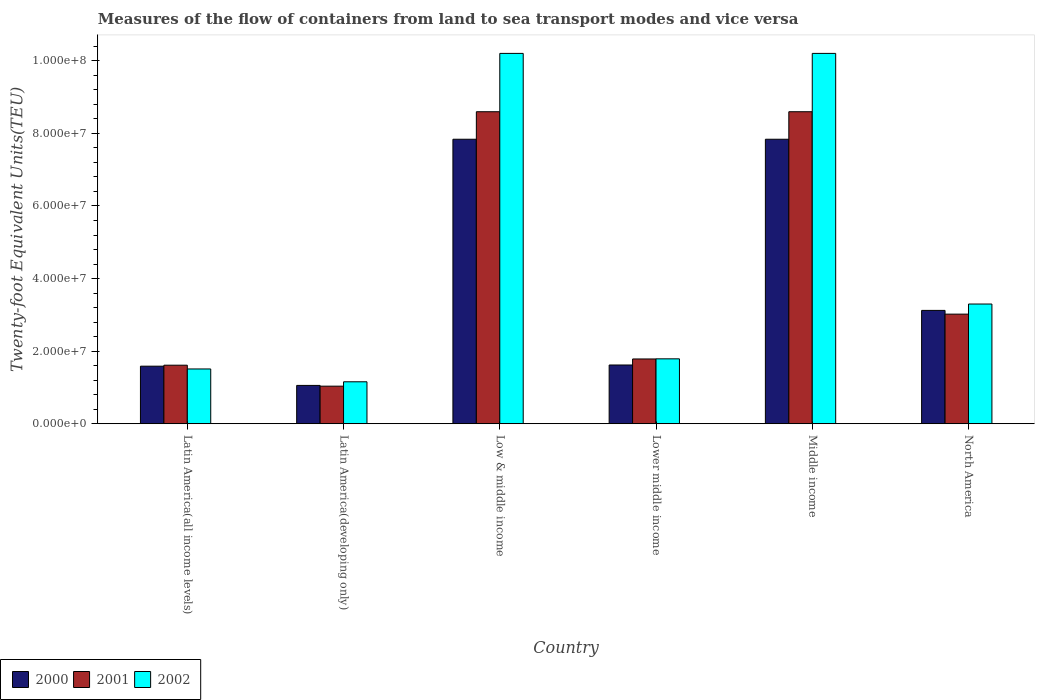How many different coloured bars are there?
Your answer should be very brief. 3. How many groups of bars are there?
Make the answer very short. 6. Are the number of bars per tick equal to the number of legend labels?
Offer a very short reply. Yes. How many bars are there on the 1st tick from the left?
Provide a short and direct response. 3. In how many cases, is the number of bars for a given country not equal to the number of legend labels?
Offer a very short reply. 0. What is the container port traffic in 2002 in Latin America(developing only)?
Offer a terse response. 1.16e+07. Across all countries, what is the maximum container port traffic in 2001?
Ensure brevity in your answer.  8.60e+07. Across all countries, what is the minimum container port traffic in 2000?
Your answer should be compact. 1.06e+07. In which country was the container port traffic in 2001 maximum?
Give a very brief answer. Low & middle income. In which country was the container port traffic in 2001 minimum?
Make the answer very short. Latin America(developing only). What is the total container port traffic in 2001 in the graph?
Provide a short and direct response. 2.46e+08. What is the difference between the container port traffic in 2001 in Lower middle income and that in North America?
Provide a succinct answer. -1.24e+07. What is the difference between the container port traffic in 2002 in Middle income and the container port traffic in 2000 in Lower middle income?
Your answer should be very brief. 8.59e+07. What is the average container port traffic in 2001 per country?
Your answer should be very brief. 4.11e+07. What is the difference between the container port traffic of/in 2002 and container port traffic of/in 2000 in Lower middle income?
Your answer should be very brief. 1.70e+06. In how many countries, is the container port traffic in 2001 greater than 72000000 TEU?
Make the answer very short. 2. What is the ratio of the container port traffic in 2002 in Latin America(all income levels) to that in Low & middle income?
Make the answer very short. 0.15. Is the difference between the container port traffic in 2002 in Latin America(developing only) and Low & middle income greater than the difference between the container port traffic in 2000 in Latin America(developing only) and Low & middle income?
Make the answer very short. No. What is the difference between the highest and the second highest container port traffic in 2001?
Provide a short and direct response. 5.58e+07. What is the difference between the highest and the lowest container port traffic in 2001?
Provide a succinct answer. 7.56e+07. In how many countries, is the container port traffic in 2000 greater than the average container port traffic in 2000 taken over all countries?
Make the answer very short. 2. Is the sum of the container port traffic in 2000 in Lower middle income and Middle income greater than the maximum container port traffic in 2001 across all countries?
Offer a terse response. Yes. What does the 3rd bar from the left in Lower middle income represents?
Ensure brevity in your answer.  2002. What does the 1st bar from the right in Middle income represents?
Offer a terse response. 2002. Is it the case that in every country, the sum of the container port traffic in 2000 and container port traffic in 2001 is greater than the container port traffic in 2002?
Provide a succinct answer. Yes. How many bars are there?
Offer a terse response. 18. What is the difference between two consecutive major ticks on the Y-axis?
Make the answer very short. 2.00e+07. Does the graph contain grids?
Your response must be concise. No. What is the title of the graph?
Offer a terse response. Measures of the flow of containers from land to sea transport modes and vice versa. Does "1984" appear as one of the legend labels in the graph?
Your response must be concise. No. What is the label or title of the X-axis?
Provide a succinct answer. Country. What is the label or title of the Y-axis?
Ensure brevity in your answer.  Twenty-foot Equivalent Units(TEU). What is the Twenty-foot Equivalent Units(TEU) in 2000 in Latin America(all income levels)?
Your response must be concise. 1.59e+07. What is the Twenty-foot Equivalent Units(TEU) in 2001 in Latin America(all income levels)?
Ensure brevity in your answer.  1.61e+07. What is the Twenty-foot Equivalent Units(TEU) in 2002 in Latin America(all income levels)?
Your response must be concise. 1.51e+07. What is the Twenty-foot Equivalent Units(TEU) in 2000 in Latin America(developing only)?
Give a very brief answer. 1.06e+07. What is the Twenty-foot Equivalent Units(TEU) in 2001 in Latin America(developing only)?
Offer a very short reply. 1.04e+07. What is the Twenty-foot Equivalent Units(TEU) in 2002 in Latin America(developing only)?
Your response must be concise. 1.16e+07. What is the Twenty-foot Equivalent Units(TEU) in 2000 in Low & middle income?
Your answer should be very brief. 7.84e+07. What is the Twenty-foot Equivalent Units(TEU) in 2001 in Low & middle income?
Provide a succinct answer. 8.60e+07. What is the Twenty-foot Equivalent Units(TEU) of 2002 in Low & middle income?
Your response must be concise. 1.02e+08. What is the Twenty-foot Equivalent Units(TEU) of 2000 in Lower middle income?
Provide a short and direct response. 1.62e+07. What is the Twenty-foot Equivalent Units(TEU) of 2001 in Lower middle income?
Ensure brevity in your answer.  1.78e+07. What is the Twenty-foot Equivalent Units(TEU) of 2002 in Lower middle income?
Your response must be concise. 1.79e+07. What is the Twenty-foot Equivalent Units(TEU) in 2000 in Middle income?
Make the answer very short. 7.84e+07. What is the Twenty-foot Equivalent Units(TEU) of 2001 in Middle income?
Offer a terse response. 8.60e+07. What is the Twenty-foot Equivalent Units(TEU) of 2002 in Middle income?
Ensure brevity in your answer.  1.02e+08. What is the Twenty-foot Equivalent Units(TEU) of 2000 in North America?
Ensure brevity in your answer.  3.12e+07. What is the Twenty-foot Equivalent Units(TEU) in 2001 in North America?
Ensure brevity in your answer.  3.02e+07. What is the Twenty-foot Equivalent Units(TEU) in 2002 in North America?
Ensure brevity in your answer.  3.30e+07. Across all countries, what is the maximum Twenty-foot Equivalent Units(TEU) of 2000?
Provide a succinct answer. 7.84e+07. Across all countries, what is the maximum Twenty-foot Equivalent Units(TEU) of 2001?
Give a very brief answer. 8.60e+07. Across all countries, what is the maximum Twenty-foot Equivalent Units(TEU) in 2002?
Your answer should be compact. 1.02e+08. Across all countries, what is the minimum Twenty-foot Equivalent Units(TEU) of 2000?
Keep it short and to the point. 1.06e+07. Across all countries, what is the minimum Twenty-foot Equivalent Units(TEU) of 2001?
Your response must be concise. 1.04e+07. Across all countries, what is the minimum Twenty-foot Equivalent Units(TEU) of 2002?
Your answer should be compact. 1.16e+07. What is the total Twenty-foot Equivalent Units(TEU) of 2000 in the graph?
Make the answer very short. 2.31e+08. What is the total Twenty-foot Equivalent Units(TEU) in 2001 in the graph?
Make the answer very short. 2.46e+08. What is the total Twenty-foot Equivalent Units(TEU) in 2002 in the graph?
Provide a short and direct response. 2.82e+08. What is the difference between the Twenty-foot Equivalent Units(TEU) of 2000 in Latin America(all income levels) and that in Latin America(developing only)?
Your answer should be compact. 5.30e+06. What is the difference between the Twenty-foot Equivalent Units(TEU) of 2001 in Latin America(all income levels) and that in Latin America(developing only)?
Ensure brevity in your answer.  5.78e+06. What is the difference between the Twenty-foot Equivalent Units(TEU) in 2002 in Latin America(all income levels) and that in Latin America(developing only)?
Provide a succinct answer. 3.53e+06. What is the difference between the Twenty-foot Equivalent Units(TEU) of 2000 in Latin America(all income levels) and that in Low & middle income?
Your answer should be compact. -6.25e+07. What is the difference between the Twenty-foot Equivalent Units(TEU) in 2001 in Latin America(all income levels) and that in Low & middle income?
Your response must be concise. -6.98e+07. What is the difference between the Twenty-foot Equivalent Units(TEU) in 2002 in Latin America(all income levels) and that in Low & middle income?
Make the answer very short. -8.69e+07. What is the difference between the Twenty-foot Equivalent Units(TEU) of 2000 in Latin America(all income levels) and that in Lower middle income?
Keep it short and to the point. -3.24e+05. What is the difference between the Twenty-foot Equivalent Units(TEU) of 2001 in Latin America(all income levels) and that in Lower middle income?
Your response must be concise. -1.72e+06. What is the difference between the Twenty-foot Equivalent Units(TEU) in 2002 in Latin America(all income levels) and that in Lower middle income?
Your answer should be compact. -2.79e+06. What is the difference between the Twenty-foot Equivalent Units(TEU) of 2000 in Latin America(all income levels) and that in Middle income?
Make the answer very short. -6.25e+07. What is the difference between the Twenty-foot Equivalent Units(TEU) in 2001 in Latin America(all income levels) and that in Middle income?
Offer a terse response. -6.98e+07. What is the difference between the Twenty-foot Equivalent Units(TEU) of 2002 in Latin America(all income levels) and that in Middle income?
Offer a very short reply. -8.69e+07. What is the difference between the Twenty-foot Equivalent Units(TEU) in 2000 in Latin America(all income levels) and that in North America?
Your answer should be very brief. -1.54e+07. What is the difference between the Twenty-foot Equivalent Units(TEU) in 2001 in Latin America(all income levels) and that in North America?
Provide a short and direct response. -1.41e+07. What is the difference between the Twenty-foot Equivalent Units(TEU) of 2002 in Latin America(all income levels) and that in North America?
Ensure brevity in your answer.  -1.79e+07. What is the difference between the Twenty-foot Equivalent Units(TEU) of 2000 in Latin America(developing only) and that in Low & middle income?
Offer a terse response. -6.78e+07. What is the difference between the Twenty-foot Equivalent Units(TEU) in 2001 in Latin America(developing only) and that in Low & middle income?
Provide a succinct answer. -7.56e+07. What is the difference between the Twenty-foot Equivalent Units(TEU) in 2002 in Latin America(developing only) and that in Low & middle income?
Your answer should be compact. -9.05e+07. What is the difference between the Twenty-foot Equivalent Units(TEU) of 2000 in Latin America(developing only) and that in Lower middle income?
Provide a short and direct response. -5.63e+06. What is the difference between the Twenty-foot Equivalent Units(TEU) of 2001 in Latin America(developing only) and that in Lower middle income?
Make the answer very short. -7.49e+06. What is the difference between the Twenty-foot Equivalent Units(TEU) of 2002 in Latin America(developing only) and that in Lower middle income?
Make the answer very short. -6.33e+06. What is the difference between the Twenty-foot Equivalent Units(TEU) in 2000 in Latin America(developing only) and that in Middle income?
Make the answer very short. -6.78e+07. What is the difference between the Twenty-foot Equivalent Units(TEU) in 2001 in Latin America(developing only) and that in Middle income?
Provide a succinct answer. -7.56e+07. What is the difference between the Twenty-foot Equivalent Units(TEU) in 2002 in Latin America(developing only) and that in Middle income?
Give a very brief answer. -9.05e+07. What is the difference between the Twenty-foot Equivalent Units(TEU) in 2000 in Latin America(developing only) and that in North America?
Give a very brief answer. -2.07e+07. What is the difference between the Twenty-foot Equivalent Units(TEU) of 2001 in Latin America(developing only) and that in North America?
Ensure brevity in your answer.  -1.98e+07. What is the difference between the Twenty-foot Equivalent Units(TEU) of 2002 in Latin America(developing only) and that in North America?
Give a very brief answer. -2.14e+07. What is the difference between the Twenty-foot Equivalent Units(TEU) in 2000 in Low & middle income and that in Lower middle income?
Keep it short and to the point. 6.22e+07. What is the difference between the Twenty-foot Equivalent Units(TEU) in 2001 in Low & middle income and that in Lower middle income?
Your answer should be compact. 6.81e+07. What is the difference between the Twenty-foot Equivalent Units(TEU) in 2002 in Low & middle income and that in Lower middle income?
Give a very brief answer. 8.42e+07. What is the difference between the Twenty-foot Equivalent Units(TEU) in 2000 in Low & middle income and that in Middle income?
Ensure brevity in your answer.  0. What is the difference between the Twenty-foot Equivalent Units(TEU) of 2001 in Low & middle income and that in Middle income?
Make the answer very short. 0. What is the difference between the Twenty-foot Equivalent Units(TEU) in 2000 in Low & middle income and that in North America?
Provide a succinct answer. 4.72e+07. What is the difference between the Twenty-foot Equivalent Units(TEU) in 2001 in Low & middle income and that in North America?
Your answer should be very brief. 5.58e+07. What is the difference between the Twenty-foot Equivalent Units(TEU) of 2002 in Low & middle income and that in North America?
Give a very brief answer. 6.91e+07. What is the difference between the Twenty-foot Equivalent Units(TEU) in 2000 in Lower middle income and that in Middle income?
Your answer should be very brief. -6.22e+07. What is the difference between the Twenty-foot Equivalent Units(TEU) in 2001 in Lower middle income and that in Middle income?
Provide a short and direct response. -6.81e+07. What is the difference between the Twenty-foot Equivalent Units(TEU) of 2002 in Lower middle income and that in Middle income?
Give a very brief answer. -8.42e+07. What is the difference between the Twenty-foot Equivalent Units(TEU) in 2000 in Lower middle income and that in North America?
Ensure brevity in your answer.  -1.50e+07. What is the difference between the Twenty-foot Equivalent Units(TEU) of 2001 in Lower middle income and that in North America?
Ensure brevity in your answer.  -1.24e+07. What is the difference between the Twenty-foot Equivalent Units(TEU) in 2002 in Lower middle income and that in North America?
Offer a very short reply. -1.51e+07. What is the difference between the Twenty-foot Equivalent Units(TEU) in 2000 in Middle income and that in North America?
Ensure brevity in your answer.  4.72e+07. What is the difference between the Twenty-foot Equivalent Units(TEU) of 2001 in Middle income and that in North America?
Provide a succinct answer. 5.58e+07. What is the difference between the Twenty-foot Equivalent Units(TEU) of 2002 in Middle income and that in North America?
Your answer should be compact. 6.91e+07. What is the difference between the Twenty-foot Equivalent Units(TEU) of 2000 in Latin America(all income levels) and the Twenty-foot Equivalent Units(TEU) of 2001 in Latin America(developing only)?
Offer a very short reply. 5.51e+06. What is the difference between the Twenty-foot Equivalent Units(TEU) of 2000 in Latin America(all income levels) and the Twenty-foot Equivalent Units(TEU) of 2002 in Latin America(developing only)?
Keep it short and to the point. 4.30e+06. What is the difference between the Twenty-foot Equivalent Units(TEU) of 2001 in Latin America(all income levels) and the Twenty-foot Equivalent Units(TEU) of 2002 in Latin America(developing only)?
Ensure brevity in your answer.  4.57e+06. What is the difference between the Twenty-foot Equivalent Units(TEU) of 2000 in Latin America(all income levels) and the Twenty-foot Equivalent Units(TEU) of 2001 in Low & middle income?
Ensure brevity in your answer.  -7.01e+07. What is the difference between the Twenty-foot Equivalent Units(TEU) of 2000 in Latin America(all income levels) and the Twenty-foot Equivalent Units(TEU) of 2002 in Low & middle income?
Keep it short and to the point. -8.62e+07. What is the difference between the Twenty-foot Equivalent Units(TEU) in 2001 in Latin America(all income levels) and the Twenty-foot Equivalent Units(TEU) in 2002 in Low & middle income?
Give a very brief answer. -8.59e+07. What is the difference between the Twenty-foot Equivalent Units(TEU) in 2000 in Latin America(all income levels) and the Twenty-foot Equivalent Units(TEU) in 2001 in Lower middle income?
Ensure brevity in your answer.  -1.99e+06. What is the difference between the Twenty-foot Equivalent Units(TEU) of 2000 in Latin America(all income levels) and the Twenty-foot Equivalent Units(TEU) of 2002 in Lower middle income?
Your response must be concise. -2.02e+06. What is the difference between the Twenty-foot Equivalent Units(TEU) in 2001 in Latin America(all income levels) and the Twenty-foot Equivalent Units(TEU) in 2002 in Lower middle income?
Provide a succinct answer. -1.75e+06. What is the difference between the Twenty-foot Equivalent Units(TEU) in 2000 in Latin America(all income levels) and the Twenty-foot Equivalent Units(TEU) in 2001 in Middle income?
Make the answer very short. -7.01e+07. What is the difference between the Twenty-foot Equivalent Units(TEU) in 2000 in Latin America(all income levels) and the Twenty-foot Equivalent Units(TEU) in 2002 in Middle income?
Give a very brief answer. -8.62e+07. What is the difference between the Twenty-foot Equivalent Units(TEU) of 2001 in Latin America(all income levels) and the Twenty-foot Equivalent Units(TEU) of 2002 in Middle income?
Ensure brevity in your answer.  -8.59e+07. What is the difference between the Twenty-foot Equivalent Units(TEU) of 2000 in Latin America(all income levels) and the Twenty-foot Equivalent Units(TEU) of 2001 in North America?
Make the answer very short. -1.43e+07. What is the difference between the Twenty-foot Equivalent Units(TEU) of 2000 in Latin America(all income levels) and the Twenty-foot Equivalent Units(TEU) of 2002 in North America?
Your response must be concise. -1.71e+07. What is the difference between the Twenty-foot Equivalent Units(TEU) of 2001 in Latin America(all income levels) and the Twenty-foot Equivalent Units(TEU) of 2002 in North America?
Provide a succinct answer. -1.69e+07. What is the difference between the Twenty-foot Equivalent Units(TEU) of 2000 in Latin America(developing only) and the Twenty-foot Equivalent Units(TEU) of 2001 in Low & middle income?
Provide a short and direct response. -7.54e+07. What is the difference between the Twenty-foot Equivalent Units(TEU) in 2000 in Latin America(developing only) and the Twenty-foot Equivalent Units(TEU) in 2002 in Low & middle income?
Give a very brief answer. -9.15e+07. What is the difference between the Twenty-foot Equivalent Units(TEU) of 2001 in Latin America(developing only) and the Twenty-foot Equivalent Units(TEU) of 2002 in Low & middle income?
Give a very brief answer. -9.17e+07. What is the difference between the Twenty-foot Equivalent Units(TEU) of 2000 in Latin America(developing only) and the Twenty-foot Equivalent Units(TEU) of 2001 in Lower middle income?
Give a very brief answer. -7.29e+06. What is the difference between the Twenty-foot Equivalent Units(TEU) of 2000 in Latin America(developing only) and the Twenty-foot Equivalent Units(TEU) of 2002 in Lower middle income?
Your response must be concise. -7.32e+06. What is the difference between the Twenty-foot Equivalent Units(TEU) in 2001 in Latin America(developing only) and the Twenty-foot Equivalent Units(TEU) in 2002 in Lower middle income?
Your response must be concise. -7.53e+06. What is the difference between the Twenty-foot Equivalent Units(TEU) in 2000 in Latin America(developing only) and the Twenty-foot Equivalent Units(TEU) in 2001 in Middle income?
Your answer should be compact. -7.54e+07. What is the difference between the Twenty-foot Equivalent Units(TEU) in 2000 in Latin America(developing only) and the Twenty-foot Equivalent Units(TEU) in 2002 in Middle income?
Make the answer very short. -9.15e+07. What is the difference between the Twenty-foot Equivalent Units(TEU) in 2001 in Latin America(developing only) and the Twenty-foot Equivalent Units(TEU) in 2002 in Middle income?
Your response must be concise. -9.17e+07. What is the difference between the Twenty-foot Equivalent Units(TEU) in 2000 in Latin America(developing only) and the Twenty-foot Equivalent Units(TEU) in 2001 in North America?
Offer a terse response. -1.96e+07. What is the difference between the Twenty-foot Equivalent Units(TEU) in 2000 in Latin America(developing only) and the Twenty-foot Equivalent Units(TEU) in 2002 in North America?
Your answer should be compact. -2.24e+07. What is the difference between the Twenty-foot Equivalent Units(TEU) of 2001 in Latin America(developing only) and the Twenty-foot Equivalent Units(TEU) of 2002 in North America?
Provide a succinct answer. -2.26e+07. What is the difference between the Twenty-foot Equivalent Units(TEU) of 2000 in Low & middle income and the Twenty-foot Equivalent Units(TEU) of 2001 in Lower middle income?
Your answer should be compact. 6.05e+07. What is the difference between the Twenty-foot Equivalent Units(TEU) of 2000 in Low & middle income and the Twenty-foot Equivalent Units(TEU) of 2002 in Lower middle income?
Offer a very short reply. 6.05e+07. What is the difference between the Twenty-foot Equivalent Units(TEU) of 2001 in Low & middle income and the Twenty-foot Equivalent Units(TEU) of 2002 in Lower middle income?
Make the answer very short. 6.81e+07. What is the difference between the Twenty-foot Equivalent Units(TEU) of 2000 in Low & middle income and the Twenty-foot Equivalent Units(TEU) of 2001 in Middle income?
Make the answer very short. -7.58e+06. What is the difference between the Twenty-foot Equivalent Units(TEU) of 2000 in Low & middle income and the Twenty-foot Equivalent Units(TEU) of 2002 in Middle income?
Your answer should be very brief. -2.37e+07. What is the difference between the Twenty-foot Equivalent Units(TEU) of 2001 in Low & middle income and the Twenty-foot Equivalent Units(TEU) of 2002 in Middle income?
Your answer should be very brief. -1.61e+07. What is the difference between the Twenty-foot Equivalent Units(TEU) in 2000 in Low & middle income and the Twenty-foot Equivalent Units(TEU) in 2001 in North America?
Offer a very short reply. 4.82e+07. What is the difference between the Twenty-foot Equivalent Units(TEU) in 2000 in Low & middle income and the Twenty-foot Equivalent Units(TEU) in 2002 in North America?
Offer a terse response. 4.54e+07. What is the difference between the Twenty-foot Equivalent Units(TEU) in 2001 in Low & middle income and the Twenty-foot Equivalent Units(TEU) in 2002 in North America?
Provide a short and direct response. 5.30e+07. What is the difference between the Twenty-foot Equivalent Units(TEU) in 2000 in Lower middle income and the Twenty-foot Equivalent Units(TEU) in 2001 in Middle income?
Make the answer very short. -6.98e+07. What is the difference between the Twenty-foot Equivalent Units(TEU) of 2000 in Lower middle income and the Twenty-foot Equivalent Units(TEU) of 2002 in Middle income?
Give a very brief answer. -8.59e+07. What is the difference between the Twenty-foot Equivalent Units(TEU) in 2001 in Lower middle income and the Twenty-foot Equivalent Units(TEU) in 2002 in Middle income?
Your answer should be very brief. -8.42e+07. What is the difference between the Twenty-foot Equivalent Units(TEU) in 2000 in Lower middle income and the Twenty-foot Equivalent Units(TEU) in 2001 in North America?
Your response must be concise. -1.40e+07. What is the difference between the Twenty-foot Equivalent Units(TEU) of 2000 in Lower middle income and the Twenty-foot Equivalent Units(TEU) of 2002 in North America?
Offer a very short reply. -1.68e+07. What is the difference between the Twenty-foot Equivalent Units(TEU) in 2001 in Lower middle income and the Twenty-foot Equivalent Units(TEU) in 2002 in North America?
Offer a very short reply. -1.51e+07. What is the difference between the Twenty-foot Equivalent Units(TEU) in 2000 in Middle income and the Twenty-foot Equivalent Units(TEU) in 2001 in North America?
Give a very brief answer. 4.82e+07. What is the difference between the Twenty-foot Equivalent Units(TEU) in 2000 in Middle income and the Twenty-foot Equivalent Units(TEU) in 2002 in North America?
Your answer should be very brief. 4.54e+07. What is the difference between the Twenty-foot Equivalent Units(TEU) in 2001 in Middle income and the Twenty-foot Equivalent Units(TEU) in 2002 in North America?
Offer a terse response. 5.30e+07. What is the average Twenty-foot Equivalent Units(TEU) in 2000 per country?
Provide a short and direct response. 3.84e+07. What is the average Twenty-foot Equivalent Units(TEU) of 2001 per country?
Give a very brief answer. 4.11e+07. What is the average Twenty-foot Equivalent Units(TEU) of 2002 per country?
Ensure brevity in your answer.  4.69e+07. What is the difference between the Twenty-foot Equivalent Units(TEU) of 2000 and Twenty-foot Equivalent Units(TEU) of 2001 in Latin America(all income levels)?
Ensure brevity in your answer.  -2.69e+05. What is the difference between the Twenty-foot Equivalent Units(TEU) in 2000 and Twenty-foot Equivalent Units(TEU) in 2002 in Latin America(all income levels)?
Provide a short and direct response. 7.70e+05. What is the difference between the Twenty-foot Equivalent Units(TEU) in 2001 and Twenty-foot Equivalent Units(TEU) in 2002 in Latin America(all income levels)?
Your answer should be very brief. 1.04e+06. What is the difference between the Twenty-foot Equivalent Units(TEU) of 2000 and Twenty-foot Equivalent Units(TEU) of 2001 in Latin America(developing only)?
Offer a terse response. 2.09e+05. What is the difference between the Twenty-foot Equivalent Units(TEU) in 2000 and Twenty-foot Equivalent Units(TEU) in 2002 in Latin America(developing only)?
Make the answer very short. -9.97e+05. What is the difference between the Twenty-foot Equivalent Units(TEU) in 2001 and Twenty-foot Equivalent Units(TEU) in 2002 in Latin America(developing only)?
Offer a very short reply. -1.21e+06. What is the difference between the Twenty-foot Equivalent Units(TEU) in 2000 and Twenty-foot Equivalent Units(TEU) in 2001 in Low & middle income?
Your answer should be very brief. -7.58e+06. What is the difference between the Twenty-foot Equivalent Units(TEU) in 2000 and Twenty-foot Equivalent Units(TEU) in 2002 in Low & middle income?
Your answer should be compact. -2.37e+07. What is the difference between the Twenty-foot Equivalent Units(TEU) in 2001 and Twenty-foot Equivalent Units(TEU) in 2002 in Low & middle income?
Your response must be concise. -1.61e+07. What is the difference between the Twenty-foot Equivalent Units(TEU) in 2000 and Twenty-foot Equivalent Units(TEU) in 2001 in Lower middle income?
Ensure brevity in your answer.  -1.66e+06. What is the difference between the Twenty-foot Equivalent Units(TEU) of 2000 and Twenty-foot Equivalent Units(TEU) of 2002 in Lower middle income?
Provide a short and direct response. -1.70e+06. What is the difference between the Twenty-foot Equivalent Units(TEU) of 2001 and Twenty-foot Equivalent Units(TEU) of 2002 in Lower middle income?
Provide a short and direct response. -3.79e+04. What is the difference between the Twenty-foot Equivalent Units(TEU) in 2000 and Twenty-foot Equivalent Units(TEU) in 2001 in Middle income?
Offer a terse response. -7.58e+06. What is the difference between the Twenty-foot Equivalent Units(TEU) of 2000 and Twenty-foot Equivalent Units(TEU) of 2002 in Middle income?
Your answer should be very brief. -2.37e+07. What is the difference between the Twenty-foot Equivalent Units(TEU) in 2001 and Twenty-foot Equivalent Units(TEU) in 2002 in Middle income?
Offer a very short reply. -1.61e+07. What is the difference between the Twenty-foot Equivalent Units(TEU) of 2000 and Twenty-foot Equivalent Units(TEU) of 2001 in North America?
Provide a succinct answer. 1.03e+06. What is the difference between the Twenty-foot Equivalent Units(TEU) of 2000 and Twenty-foot Equivalent Units(TEU) of 2002 in North America?
Ensure brevity in your answer.  -1.76e+06. What is the difference between the Twenty-foot Equivalent Units(TEU) in 2001 and Twenty-foot Equivalent Units(TEU) in 2002 in North America?
Provide a succinct answer. -2.79e+06. What is the ratio of the Twenty-foot Equivalent Units(TEU) of 2000 in Latin America(all income levels) to that in Latin America(developing only)?
Your response must be concise. 1.5. What is the ratio of the Twenty-foot Equivalent Units(TEU) in 2001 in Latin America(all income levels) to that in Latin America(developing only)?
Provide a short and direct response. 1.56. What is the ratio of the Twenty-foot Equivalent Units(TEU) of 2002 in Latin America(all income levels) to that in Latin America(developing only)?
Your answer should be very brief. 1.31. What is the ratio of the Twenty-foot Equivalent Units(TEU) of 2000 in Latin America(all income levels) to that in Low & middle income?
Provide a succinct answer. 0.2. What is the ratio of the Twenty-foot Equivalent Units(TEU) in 2001 in Latin America(all income levels) to that in Low & middle income?
Offer a very short reply. 0.19. What is the ratio of the Twenty-foot Equivalent Units(TEU) in 2002 in Latin America(all income levels) to that in Low & middle income?
Your response must be concise. 0.15. What is the ratio of the Twenty-foot Equivalent Units(TEU) of 2001 in Latin America(all income levels) to that in Lower middle income?
Give a very brief answer. 0.9. What is the ratio of the Twenty-foot Equivalent Units(TEU) of 2002 in Latin America(all income levels) to that in Lower middle income?
Offer a very short reply. 0.84. What is the ratio of the Twenty-foot Equivalent Units(TEU) in 2000 in Latin America(all income levels) to that in Middle income?
Your answer should be compact. 0.2. What is the ratio of the Twenty-foot Equivalent Units(TEU) of 2001 in Latin America(all income levels) to that in Middle income?
Offer a very short reply. 0.19. What is the ratio of the Twenty-foot Equivalent Units(TEU) in 2002 in Latin America(all income levels) to that in Middle income?
Make the answer very short. 0.15. What is the ratio of the Twenty-foot Equivalent Units(TEU) of 2000 in Latin America(all income levels) to that in North America?
Your answer should be very brief. 0.51. What is the ratio of the Twenty-foot Equivalent Units(TEU) in 2001 in Latin America(all income levels) to that in North America?
Your answer should be very brief. 0.53. What is the ratio of the Twenty-foot Equivalent Units(TEU) in 2002 in Latin America(all income levels) to that in North America?
Your response must be concise. 0.46. What is the ratio of the Twenty-foot Equivalent Units(TEU) in 2000 in Latin America(developing only) to that in Low & middle income?
Ensure brevity in your answer.  0.13. What is the ratio of the Twenty-foot Equivalent Units(TEU) of 2001 in Latin America(developing only) to that in Low & middle income?
Give a very brief answer. 0.12. What is the ratio of the Twenty-foot Equivalent Units(TEU) of 2002 in Latin America(developing only) to that in Low & middle income?
Give a very brief answer. 0.11. What is the ratio of the Twenty-foot Equivalent Units(TEU) in 2000 in Latin America(developing only) to that in Lower middle income?
Your answer should be very brief. 0.65. What is the ratio of the Twenty-foot Equivalent Units(TEU) of 2001 in Latin America(developing only) to that in Lower middle income?
Offer a very short reply. 0.58. What is the ratio of the Twenty-foot Equivalent Units(TEU) in 2002 in Latin America(developing only) to that in Lower middle income?
Ensure brevity in your answer.  0.65. What is the ratio of the Twenty-foot Equivalent Units(TEU) of 2000 in Latin America(developing only) to that in Middle income?
Your response must be concise. 0.13. What is the ratio of the Twenty-foot Equivalent Units(TEU) in 2001 in Latin America(developing only) to that in Middle income?
Give a very brief answer. 0.12. What is the ratio of the Twenty-foot Equivalent Units(TEU) of 2002 in Latin America(developing only) to that in Middle income?
Offer a very short reply. 0.11. What is the ratio of the Twenty-foot Equivalent Units(TEU) in 2000 in Latin America(developing only) to that in North America?
Offer a terse response. 0.34. What is the ratio of the Twenty-foot Equivalent Units(TEU) in 2001 in Latin America(developing only) to that in North America?
Provide a succinct answer. 0.34. What is the ratio of the Twenty-foot Equivalent Units(TEU) of 2002 in Latin America(developing only) to that in North America?
Your response must be concise. 0.35. What is the ratio of the Twenty-foot Equivalent Units(TEU) of 2000 in Low & middle income to that in Lower middle income?
Offer a very short reply. 4.84. What is the ratio of the Twenty-foot Equivalent Units(TEU) in 2001 in Low & middle income to that in Lower middle income?
Your answer should be very brief. 4.82. What is the ratio of the Twenty-foot Equivalent Units(TEU) of 2002 in Low & middle income to that in Lower middle income?
Offer a terse response. 5.71. What is the ratio of the Twenty-foot Equivalent Units(TEU) of 2000 in Low & middle income to that in Middle income?
Provide a succinct answer. 1. What is the ratio of the Twenty-foot Equivalent Units(TEU) of 2002 in Low & middle income to that in Middle income?
Provide a succinct answer. 1. What is the ratio of the Twenty-foot Equivalent Units(TEU) of 2000 in Low & middle income to that in North America?
Your response must be concise. 2.51. What is the ratio of the Twenty-foot Equivalent Units(TEU) in 2001 in Low & middle income to that in North America?
Your answer should be very brief. 2.85. What is the ratio of the Twenty-foot Equivalent Units(TEU) of 2002 in Low & middle income to that in North America?
Give a very brief answer. 3.09. What is the ratio of the Twenty-foot Equivalent Units(TEU) in 2000 in Lower middle income to that in Middle income?
Ensure brevity in your answer.  0.21. What is the ratio of the Twenty-foot Equivalent Units(TEU) in 2001 in Lower middle income to that in Middle income?
Keep it short and to the point. 0.21. What is the ratio of the Twenty-foot Equivalent Units(TEU) of 2002 in Lower middle income to that in Middle income?
Your response must be concise. 0.18. What is the ratio of the Twenty-foot Equivalent Units(TEU) of 2000 in Lower middle income to that in North America?
Your answer should be very brief. 0.52. What is the ratio of the Twenty-foot Equivalent Units(TEU) of 2001 in Lower middle income to that in North America?
Make the answer very short. 0.59. What is the ratio of the Twenty-foot Equivalent Units(TEU) of 2002 in Lower middle income to that in North America?
Offer a terse response. 0.54. What is the ratio of the Twenty-foot Equivalent Units(TEU) of 2000 in Middle income to that in North America?
Your response must be concise. 2.51. What is the ratio of the Twenty-foot Equivalent Units(TEU) of 2001 in Middle income to that in North America?
Offer a terse response. 2.85. What is the ratio of the Twenty-foot Equivalent Units(TEU) of 2002 in Middle income to that in North America?
Offer a terse response. 3.09. What is the difference between the highest and the second highest Twenty-foot Equivalent Units(TEU) of 2000?
Your response must be concise. 0. What is the difference between the highest and the second highest Twenty-foot Equivalent Units(TEU) in 2002?
Give a very brief answer. 0. What is the difference between the highest and the lowest Twenty-foot Equivalent Units(TEU) of 2000?
Your answer should be very brief. 6.78e+07. What is the difference between the highest and the lowest Twenty-foot Equivalent Units(TEU) in 2001?
Provide a short and direct response. 7.56e+07. What is the difference between the highest and the lowest Twenty-foot Equivalent Units(TEU) in 2002?
Provide a short and direct response. 9.05e+07. 